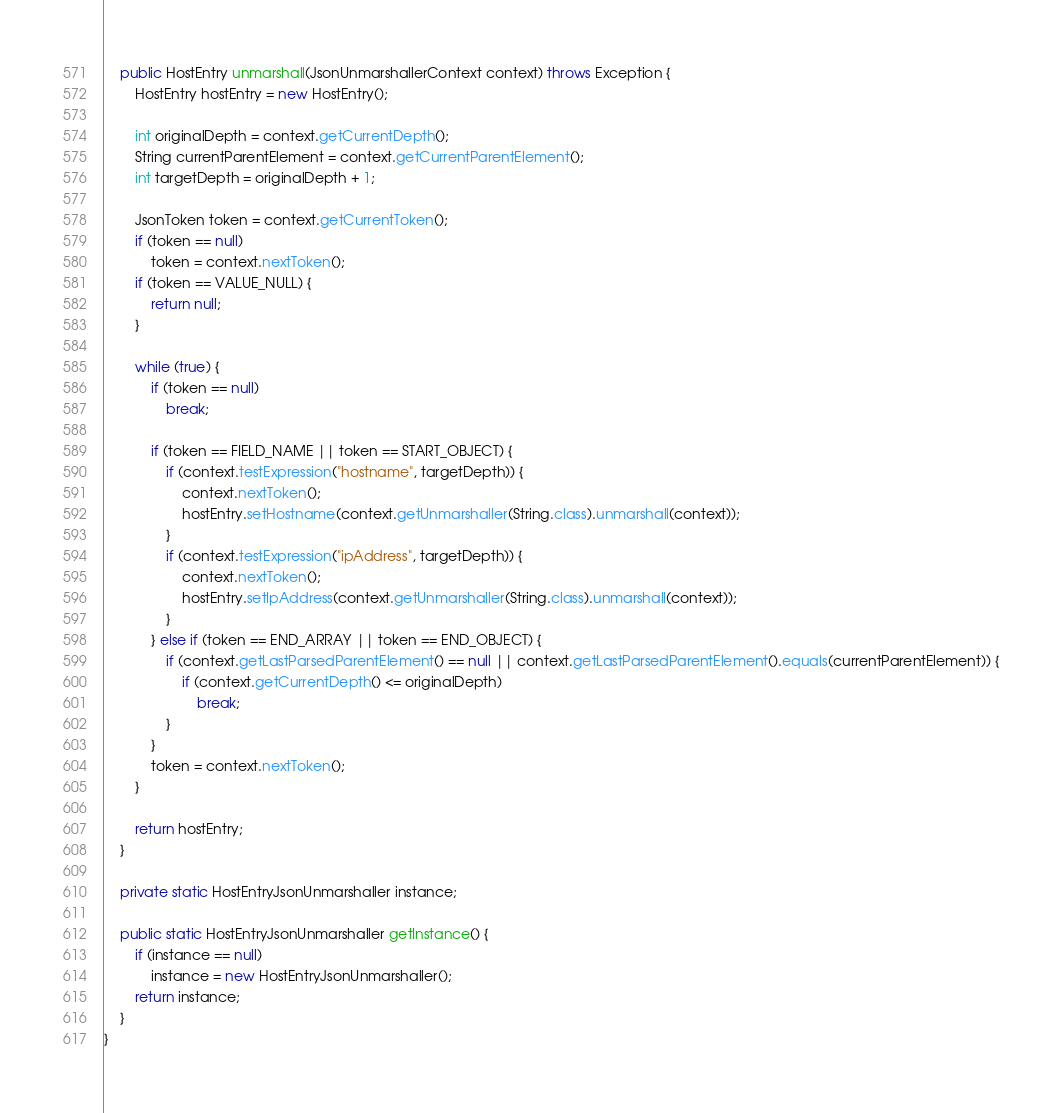Convert code to text. <code><loc_0><loc_0><loc_500><loc_500><_Java_>    public HostEntry unmarshall(JsonUnmarshallerContext context) throws Exception {
        HostEntry hostEntry = new HostEntry();

        int originalDepth = context.getCurrentDepth();
        String currentParentElement = context.getCurrentParentElement();
        int targetDepth = originalDepth + 1;

        JsonToken token = context.getCurrentToken();
        if (token == null)
            token = context.nextToken();
        if (token == VALUE_NULL) {
            return null;
        }

        while (true) {
            if (token == null)
                break;

            if (token == FIELD_NAME || token == START_OBJECT) {
                if (context.testExpression("hostname", targetDepth)) {
                    context.nextToken();
                    hostEntry.setHostname(context.getUnmarshaller(String.class).unmarshall(context));
                }
                if (context.testExpression("ipAddress", targetDepth)) {
                    context.nextToken();
                    hostEntry.setIpAddress(context.getUnmarshaller(String.class).unmarshall(context));
                }
            } else if (token == END_ARRAY || token == END_OBJECT) {
                if (context.getLastParsedParentElement() == null || context.getLastParsedParentElement().equals(currentParentElement)) {
                    if (context.getCurrentDepth() <= originalDepth)
                        break;
                }
            }
            token = context.nextToken();
        }

        return hostEntry;
    }

    private static HostEntryJsonUnmarshaller instance;

    public static HostEntryJsonUnmarshaller getInstance() {
        if (instance == null)
            instance = new HostEntryJsonUnmarshaller();
        return instance;
    }
}
</code> 